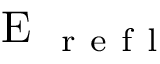<formula> <loc_0><loc_0><loc_500><loc_500>E _ { r e f l }</formula> 